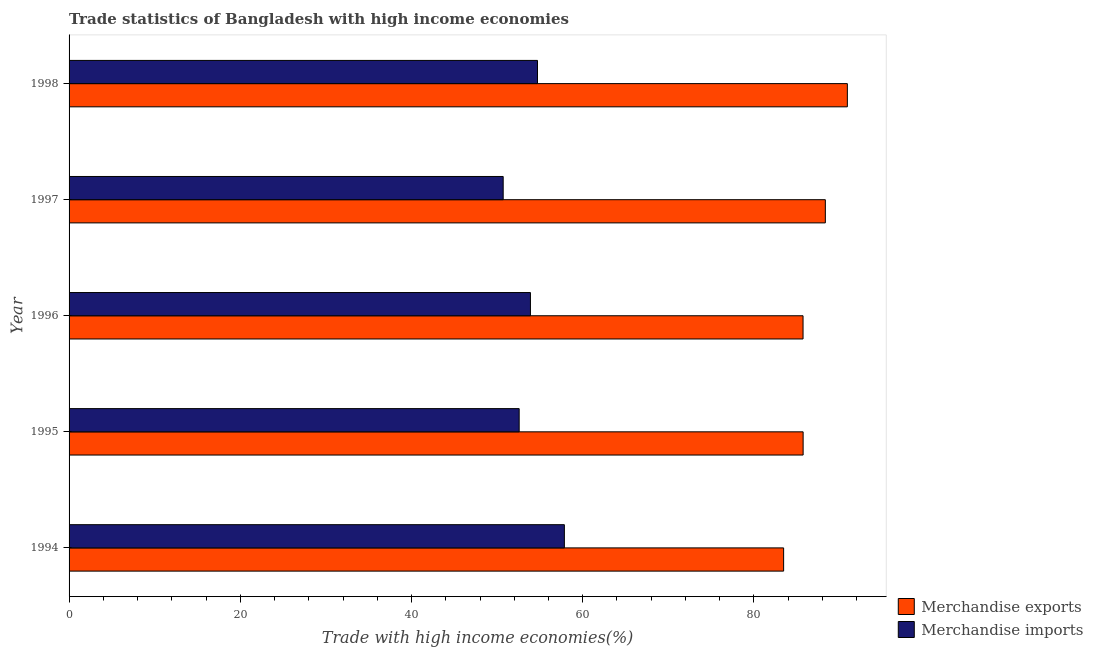Are the number of bars on each tick of the Y-axis equal?
Ensure brevity in your answer.  Yes. How many bars are there on the 5th tick from the top?
Your response must be concise. 2. What is the label of the 3rd group of bars from the top?
Offer a terse response. 1996. In how many cases, is the number of bars for a given year not equal to the number of legend labels?
Your answer should be very brief. 0. What is the merchandise exports in 1997?
Offer a very short reply. 88.34. Across all years, what is the maximum merchandise imports?
Offer a very short reply. 57.86. Across all years, what is the minimum merchandise exports?
Provide a succinct answer. 83.47. In which year was the merchandise imports minimum?
Offer a very short reply. 1997. What is the total merchandise imports in the graph?
Your answer should be compact. 269.75. What is the difference between the merchandise exports in 1994 and that in 1995?
Ensure brevity in your answer.  -2.28. What is the difference between the merchandise imports in 1998 and the merchandise exports in 1996?
Your answer should be very brief. -31.02. What is the average merchandise exports per year?
Your answer should be very brief. 86.84. In the year 1997, what is the difference between the merchandise exports and merchandise imports?
Provide a short and direct response. 37.63. What is the ratio of the merchandise imports in 1995 to that in 1997?
Make the answer very short. 1.04. Is the difference between the merchandise imports in 1994 and 1995 greater than the difference between the merchandise exports in 1994 and 1995?
Ensure brevity in your answer.  Yes. What is the difference between the highest and the second highest merchandise imports?
Offer a terse response. 3.14. What is the difference between the highest and the lowest merchandise imports?
Provide a succinct answer. 7.15. In how many years, is the merchandise imports greater than the average merchandise imports taken over all years?
Give a very brief answer. 2. Is the sum of the merchandise imports in 1997 and 1998 greater than the maximum merchandise exports across all years?
Your answer should be very brief. Yes. What does the 1st bar from the top in 1998 represents?
Offer a very short reply. Merchandise imports. What does the 1st bar from the bottom in 1994 represents?
Keep it short and to the point. Merchandise exports. Are all the bars in the graph horizontal?
Provide a short and direct response. Yes. How many years are there in the graph?
Give a very brief answer. 5. What is the difference between two consecutive major ticks on the X-axis?
Your answer should be compact. 20. Does the graph contain grids?
Ensure brevity in your answer.  No. How many legend labels are there?
Provide a succinct answer. 2. How are the legend labels stacked?
Provide a succinct answer. Vertical. What is the title of the graph?
Make the answer very short. Trade statistics of Bangladesh with high income economies. What is the label or title of the X-axis?
Your answer should be compact. Trade with high income economies(%). What is the Trade with high income economies(%) of Merchandise exports in 1994?
Offer a terse response. 83.47. What is the Trade with high income economies(%) in Merchandise imports in 1994?
Your response must be concise. 57.86. What is the Trade with high income economies(%) of Merchandise exports in 1995?
Provide a short and direct response. 85.74. What is the Trade with high income economies(%) in Merchandise imports in 1995?
Your answer should be very brief. 52.58. What is the Trade with high income economies(%) of Merchandise exports in 1996?
Offer a terse response. 85.74. What is the Trade with high income economies(%) of Merchandise imports in 1996?
Keep it short and to the point. 53.89. What is the Trade with high income economies(%) of Merchandise exports in 1997?
Give a very brief answer. 88.34. What is the Trade with high income economies(%) of Merchandise imports in 1997?
Offer a very short reply. 50.71. What is the Trade with high income economies(%) in Merchandise exports in 1998?
Provide a succinct answer. 90.91. What is the Trade with high income economies(%) of Merchandise imports in 1998?
Make the answer very short. 54.72. Across all years, what is the maximum Trade with high income economies(%) of Merchandise exports?
Make the answer very short. 90.91. Across all years, what is the maximum Trade with high income economies(%) of Merchandise imports?
Offer a terse response. 57.86. Across all years, what is the minimum Trade with high income economies(%) in Merchandise exports?
Offer a very short reply. 83.47. Across all years, what is the minimum Trade with high income economies(%) in Merchandise imports?
Your answer should be very brief. 50.71. What is the total Trade with high income economies(%) in Merchandise exports in the graph?
Offer a very short reply. 434.2. What is the total Trade with high income economies(%) in Merchandise imports in the graph?
Give a very brief answer. 269.75. What is the difference between the Trade with high income economies(%) in Merchandise exports in 1994 and that in 1995?
Provide a succinct answer. -2.28. What is the difference between the Trade with high income economies(%) of Merchandise imports in 1994 and that in 1995?
Offer a terse response. 5.28. What is the difference between the Trade with high income economies(%) in Merchandise exports in 1994 and that in 1996?
Your answer should be very brief. -2.27. What is the difference between the Trade with high income economies(%) in Merchandise imports in 1994 and that in 1996?
Keep it short and to the point. 3.96. What is the difference between the Trade with high income economies(%) of Merchandise exports in 1994 and that in 1997?
Your answer should be compact. -4.87. What is the difference between the Trade with high income economies(%) in Merchandise imports in 1994 and that in 1997?
Offer a very short reply. 7.15. What is the difference between the Trade with high income economies(%) of Merchandise exports in 1994 and that in 1998?
Your answer should be very brief. -7.44. What is the difference between the Trade with high income economies(%) in Merchandise imports in 1994 and that in 1998?
Provide a succinct answer. 3.14. What is the difference between the Trade with high income economies(%) of Merchandise exports in 1995 and that in 1996?
Your answer should be very brief. 0.01. What is the difference between the Trade with high income economies(%) of Merchandise imports in 1995 and that in 1996?
Offer a very short reply. -1.32. What is the difference between the Trade with high income economies(%) of Merchandise exports in 1995 and that in 1997?
Keep it short and to the point. -2.6. What is the difference between the Trade with high income economies(%) in Merchandise imports in 1995 and that in 1997?
Your answer should be compact. 1.87. What is the difference between the Trade with high income economies(%) of Merchandise exports in 1995 and that in 1998?
Your response must be concise. -5.17. What is the difference between the Trade with high income economies(%) in Merchandise imports in 1995 and that in 1998?
Your response must be concise. -2.14. What is the difference between the Trade with high income economies(%) in Merchandise exports in 1996 and that in 1997?
Provide a succinct answer. -2.6. What is the difference between the Trade with high income economies(%) of Merchandise imports in 1996 and that in 1997?
Give a very brief answer. 3.18. What is the difference between the Trade with high income economies(%) in Merchandise exports in 1996 and that in 1998?
Offer a very short reply. -5.18. What is the difference between the Trade with high income economies(%) in Merchandise imports in 1996 and that in 1998?
Keep it short and to the point. -0.82. What is the difference between the Trade with high income economies(%) of Merchandise exports in 1997 and that in 1998?
Provide a short and direct response. -2.57. What is the difference between the Trade with high income economies(%) in Merchandise imports in 1997 and that in 1998?
Your answer should be very brief. -4.01. What is the difference between the Trade with high income economies(%) of Merchandise exports in 1994 and the Trade with high income economies(%) of Merchandise imports in 1995?
Provide a short and direct response. 30.89. What is the difference between the Trade with high income economies(%) in Merchandise exports in 1994 and the Trade with high income economies(%) in Merchandise imports in 1996?
Your answer should be very brief. 29.58. What is the difference between the Trade with high income economies(%) in Merchandise exports in 1994 and the Trade with high income economies(%) in Merchandise imports in 1997?
Give a very brief answer. 32.76. What is the difference between the Trade with high income economies(%) in Merchandise exports in 1994 and the Trade with high income economies(%) in Merchandise imports in 1998?
Make the answer very short. 28.75. What is the difference between the Trade with high income economies(%) of Merchandise exports in 1995 and the Trade with high income economies(%) of Merchandise imports in 1996?
Offer a terse response. 31.85. What is the difference between the Trade with high income economies(%) of Merchandise exports in 1995 and the Trade with high income economies(%) of Merchandise imports in 1997?
Ensure brevity in your answer.  35.04. What is the difference between the Trade with high income economies(%) of Merchandise exports in 1995 and the Trade with high income economies(%) of Merchandise imports in 1998?
Offer a very short reply. 31.03. What is the difference between the Trade with high income economies(%) of Merchandise exports in 1996 and the Trade with high income economies(%) of Merchandise imports in 1997?
Ensure brevity in your answer.  35.03. What is the difference between the Trade with high income economies(%) in Merchandise exports in 1996 and the Trade with high income economies(%) in Merchandise imports in 1998?
Offer a very short reply. 31.02. What is the difference between the Trade with high income economies(%) of Merchandise exports in 1997 and the Trade with high income economies(%) of Merchandise imports in 1998?
Provide a short and direct response. 33.62. What is the average Trade with high income economies(%) of Merchandise exports per year?
Your response must be concise. 86.84. What is the average Trade with high income economies(%) of Merchandise imports per year?
Ensure brevity in your answer.  53.95. In the year 1994, what is the difference between the Trade with high income economies(%) of Merchandise exports and Trade with high income economies(%) of Merchandise imports?
Keep it short and to the point. 25.61. In the year 1995, what is the difference between the Trade with high income economies(%) of Merchandise exports and Trade with high income economies(%) of Merchandise imports?
Make the answer very short. 33.17. In the year 1996, what is the difference between the Trade with high income economies(%) in Merchandise exports and Trade with high income economies(%) in Merchandise imports?
Your response must be concise. 31.84. In the year 1997, what is the difference between the Trade with high income economies(%) in Merchandise exports and Trade with high income economies(%) in Merchandise imports?
Your answer should be compact. 37.63. In the year 1998, what is the difference between the Trade with high income economies(%) in Merchandise exports and Trade with high income economies(%) in Merchandise imports?
Provide a short and direct response. 36.2. What is the ratio of the Trade with high income economies(%) in Merchandise exports in 1994 to that in 1995?
Your answer should be compact. 0.97. What is the ratio of the Trade with high income economies(%) of Merchandise imports in 1994 to that in 1995?
Provide a short and direct response. 1.1. What is the ratio of the Trade with high income economies(%) of Merchandise exports in 1994 to that in 1996?
Ensure brevity in your answer.  0.97. What is the ratio of the Trade with high income economies(%) of Merchandise imports in 1994 to that in 1996?
Your answer should be compact. 1.07. What is the ratio of the Trade with high income economies(%) of Merchandise exports in 1994 to that in 1997?
Ensure brevity in your answer.  0.94. What is the ratio of the Trade with high income economies(%) in Merchandise imports in 1994 to that in 1997?
Provide a short and direct response. 1.14. What is the ratio of the Trade with high income economies(%) of Merchandise exports in 1994 to that in 1998?
Make the answer very short. 0.92. What is the ratio of the Trade with high income economies(%) in Merchandise imports in 1994 to that in 1998?
Give a very brief answer. 1.06. What is the ratio of the Trade with high income economies(%) of Merchandise exports in 1995 to that in 1996?
Offer a terse response. 1. What is the ratio of the Trade with high income economies(%) in Merchandise imports in 1995 to that in 1996?
Make the answer very short. 0.98. What is the ratio of the Trade with high income economies(%) of Merchandise exports in 1995 to that in 1997?
Ensure brevity in your answer.  0.97. What is the ratio of the Trade with high income economies(%) of Merchandise imports in 1995 to that in 1997?
Offer a very short reply. 1.04. What is the ratio of the Trade with high income economies(%) of Merchandise exports in 1995 to that in 1998?
Your response must be concise. 0.94. What is the ratio of the Trade with high income economies(%) in Merchandise imports in 1995 to that in 1998?
Your response must be concise. 0.96. What is the ratio of the Trade with high income economies(%) in Merchandise exports in 1996 to that in 1997?
Provide a succinct answer. 0.97. What is the ratio of the Trade with high income economies(%) of Merchandise imports in 1996 to that in 1997?
Keep it short and to the point. 1.06. What is the ratio of the Trade with high income economies(%) in Merchandise exports in 1996 to that in 1998?
Provide a short and direct response. 0.94. What is the ratio of the Trade with high income economies(%) of Merchandise imports in 1996 to that in 1998?
Your answer should be very brief. 0.98. What is the ratio of the Trade with high income economies(%) in Merchandise exports in 1997 to that in 1998?
Provide a short and direct response. 0.97. What is the ratio of the Trade with high income economies(%) of Merchandise imports in 1997 to that in 1998?
Keep it short and to the point. 0.93. What is the difference between the highest and the second highest Trade with high income economies(%) in Merchandise exports?
Provide a short and direct response. 2.57. What is the difference between the highest and the second highest Trade with high income economies(%) of Merchandise imports?
Offer a terse response. 3.14. What is the difference between the highest and the lowest Trade with high income economies(%) in Merchandise exports?
Offer a very short reply. 7.44. What is the difference between the highest and the lowest Trade with high income economies(%) in Merchandise imports?
Keep it short and to the point. 7.15. 